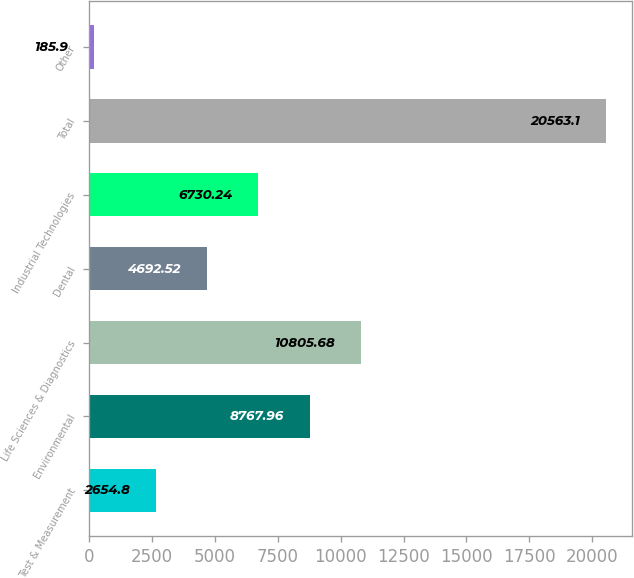<chart> <loc_0><loc_0><loc_500><loc_500><bar_chart><fcel>Test & Measurement<fcel>Environmental<fcel>Life Sciences & Diagnostics<fcel>Dental<fcel>Industrial Technologies<fcel>Total<fcel>Other<nl><fcel>2654.8<fcel>8767.96<fcel>10805.7<fcel>4692.52<fcel>6730.24<fcel>20563.1<fcel>185.9<nl></chart> 